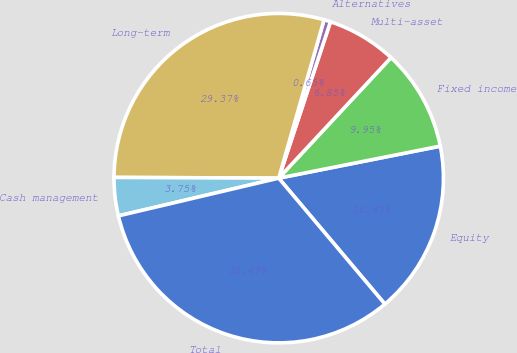Convert chart to OTSL. <chart><loc_0><loc_0><loc_500><loc_500><pie_chart><fcel>Equity<fcel>Fixed income<fcel>Multi-asset<fcel>Alternatives<fcel>Long-term<fcel>Cash management<fcel>Total<nl><fcel>16.97%<fcel>9.95%<fcel>6.85%<fcel>0.65%<fcel>29.37%<fcel>3.75%<fcel>32.47%<nl></chart> 